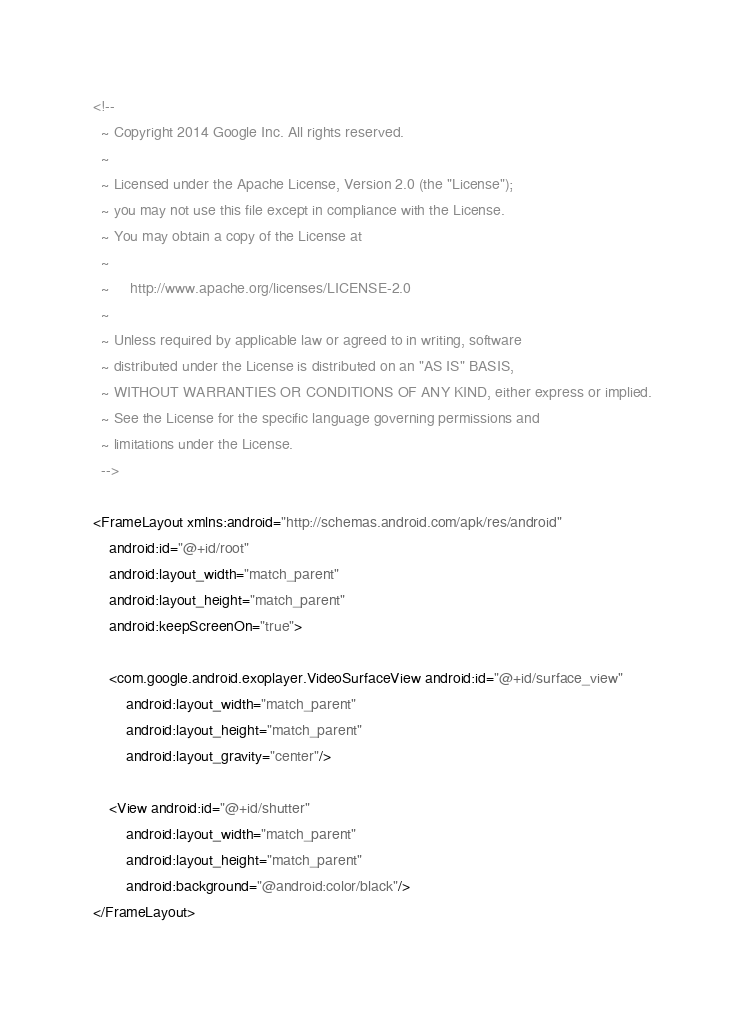Convert code to text. <code><loc_0><loc_0><loc_500><loc_500><_XML_><!--
  ~ Copyright 2014 Google Inc. All rights reserved.
  ~
  ~ Licensed under the Apache License, Version 2.0 (the "License");
  ~ you may not use this file except in compliance with the License.
  ~ You may obtain a copy of the License at
  ~
  ~     http://www.apache.org/licenses/LICENSE-2.0
  ~
  ~ Unless required by applicable law or agreed to in writing, software
  ~ distributed under the License is distributed on an "AS IS" BASIS,
  ~ WITHOUT WARRANTIES OR CONDITIONS OF ANY KIND, either express or implied.
  ~ See the License for the specific language governing permissions and
  ~ limitations under the License.
  -->

<FrameLayout xmlns:android="http://schemas.android.com/apk/res/android"
    android:id="@+id/root"
    android:layout_width="match_parent"
    android:layout_height="match_parent"
    android:keepScreenOn="true">

    <com.google.android.exoplayer.VideoSurfaceView android:id="@+id/surface_view"
        android:layout_width="match_parent"
        android:layout_height="match_parent"
        android:layout_gravity="center"/>

    <View android:id="@+id/shutter"
        android:layout_width="match_parent"
        android:layout_height="match_parent"
        android:background="@android:color/black"/>
</FrameLayout></code> 